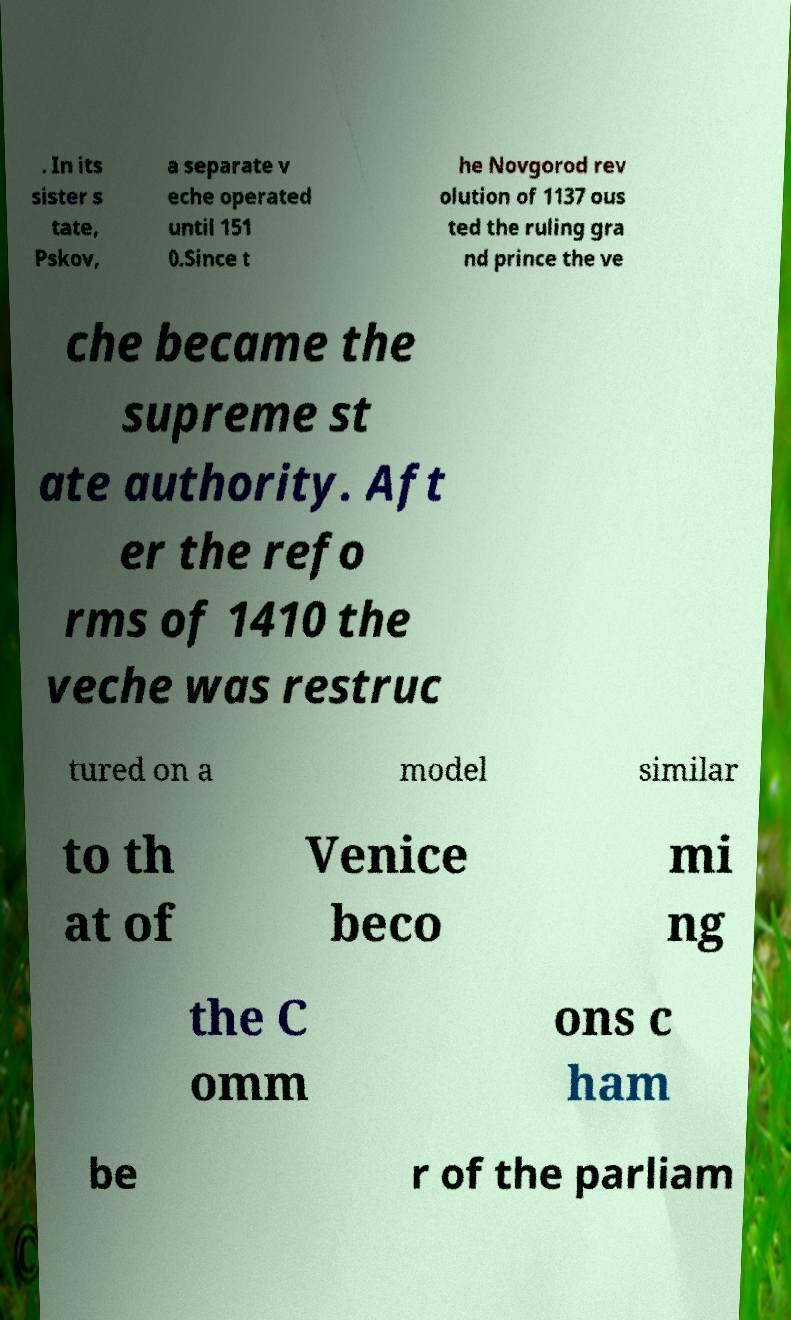Please identify and transcribe the text found in this image. . In its sister s tate, Pskov, a separate v eche operated until 151 0.Since t he Novgorod rev olution of 1137 ous ted the ruling gra nd prince the ve che became the supreme st ate authority. Aft er the refo rms of 1410 the veche was restruc tured on a model similar to th at of Venice beco mi ng the C omm ons c ham be r of the parliam 